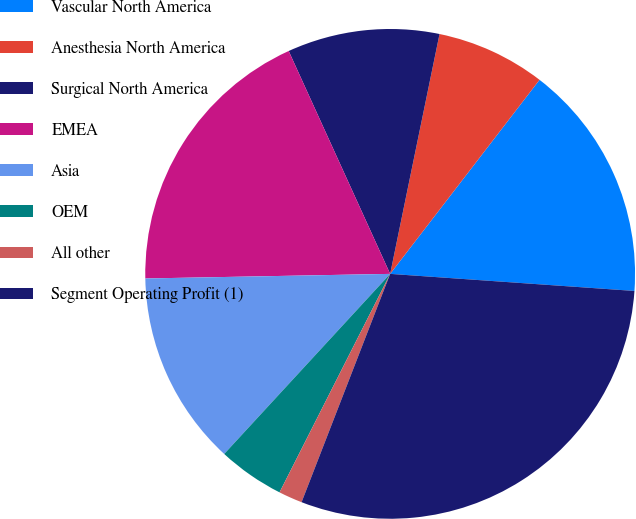<chart> <loc_0><loc_0><loc_500><loc_500><pie_chart><fcel>Vascular North America<fcel>Anesthesia North America<fcel>Surgical North America<fcel>EMEA<fcel>Asia<fcel>OEM<fcel>All other<fcel>Segment Operating Profit (1)<nl><fcel>15.67%<fcel>7.21%<fcel>10.03%<fcel>18.5%<fcel>12.85%<fcel>4.39%<fcel>1.57%<fcel>29.78%<nl></chart> 